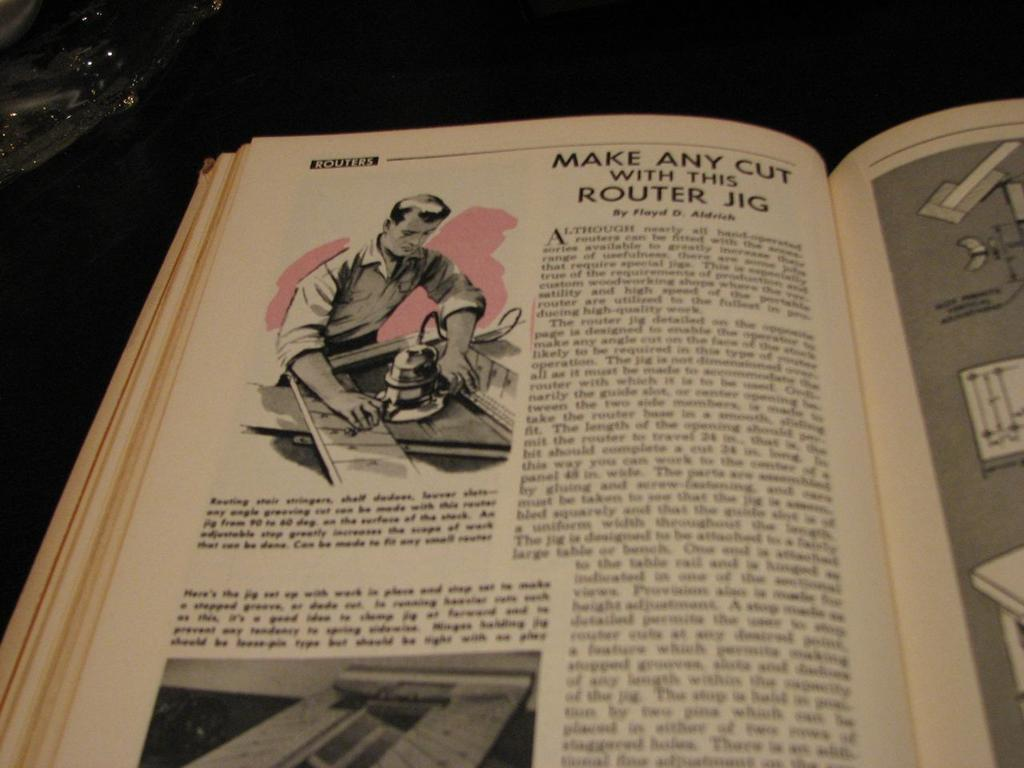<image>
Summarize the visual content of the image. Open book on a page which says "Make any cut". 